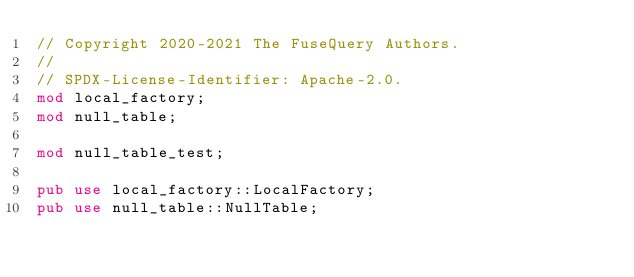Convert code to text. <code><loc_0><loc_0><loc_500><loc_500><_Rust_>// Copyright 2020-2021 The FuseQuery Authors.
//
// SPDX-License-Identifier: Apache-2.0.
mod local_factory;
mod null_table;

mod null_table_test;

pub use local_factory::LocalFactory;
pub use null_table::NullTable;
</code> 